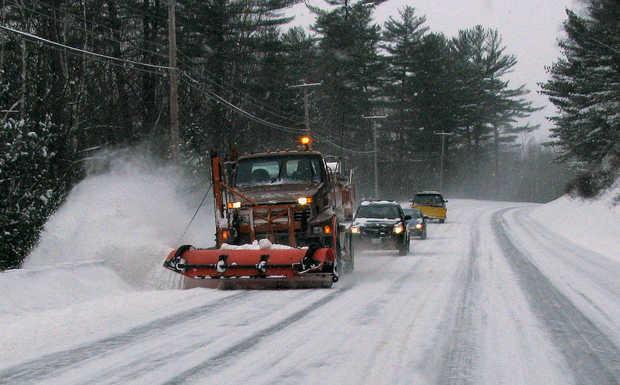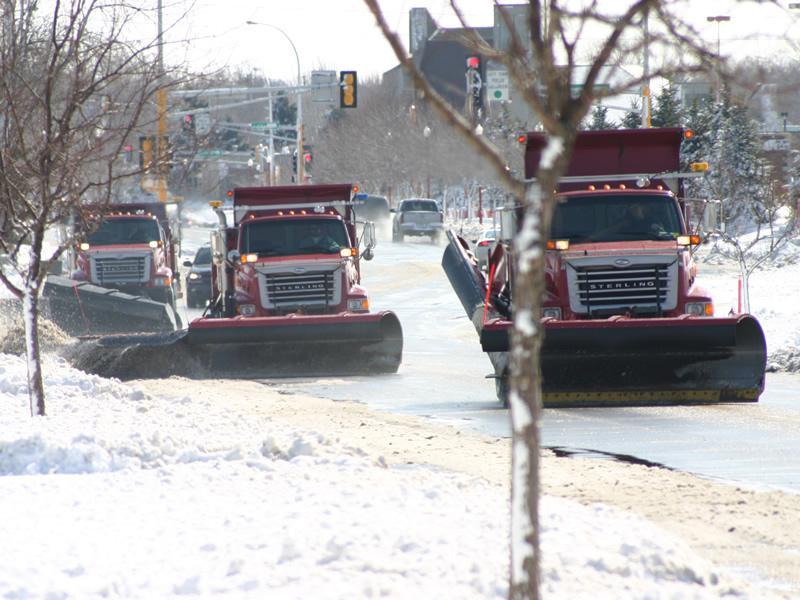The first image is the image on the left, the second image is the image on the right. Analyze the images presented: Is the assertion "An image shows at least one yellow truck clearing snow with a plow." valid? Answer yes or no. No. 